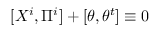<formula> <loc_0><loc_0><loc_500><loc_500>[ X ^ { i } , \Pi ^ { i } ] + [ \theta , \theta ^ { t } ] \equiv 0</formula> 